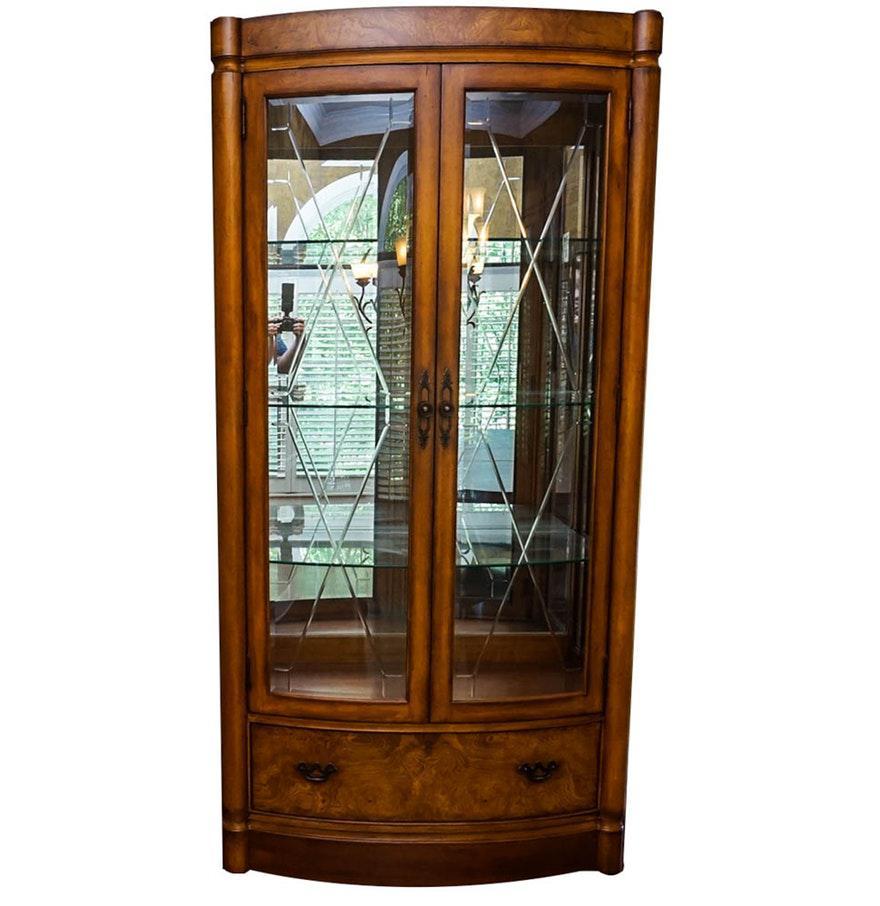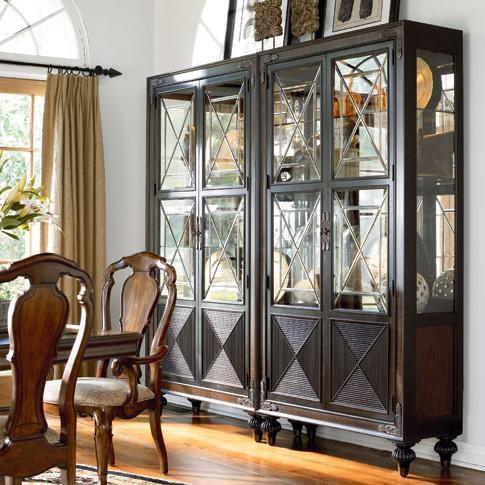The first image is the image on the left, the second image is the image on the right. For the images shown, is this caption "The right hand image has a row of three drawers." true? Answer yes or no. No. 